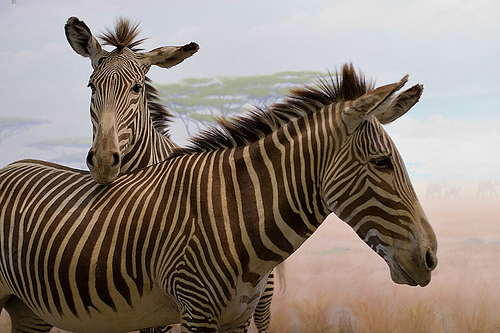Please provide a short description for this region: [0.17, 0.31, 0.28, 0.38]. The region depicts two alert and striking eyes of a zebra, their watchful gaze adding to the intense expression typically seen in these majestic animals. 